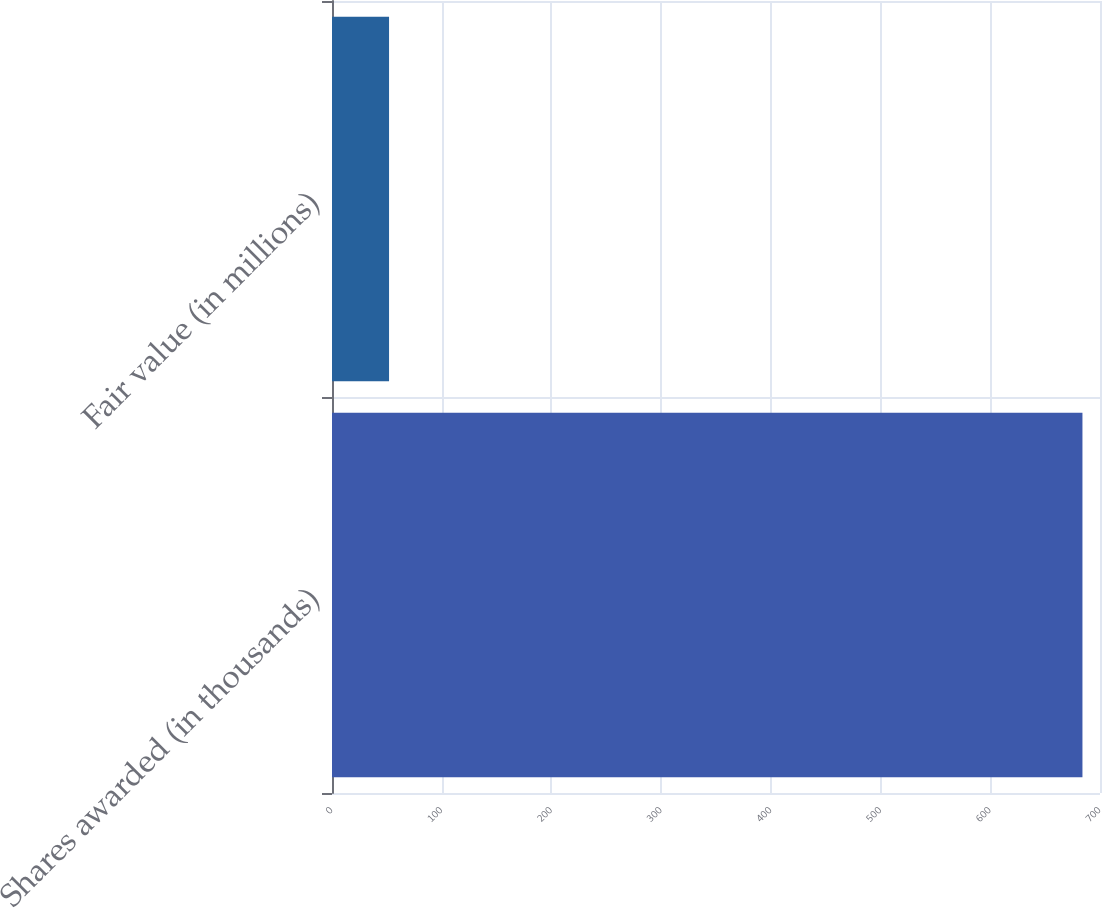<chart> <loc_0><loc_0><loc_500><loc_500><bar_chart><fcel>Shares awarded (in thousands)<fcel>Fair value (in millions)<nl><fcel>684<fcel>52<nl></chart> 